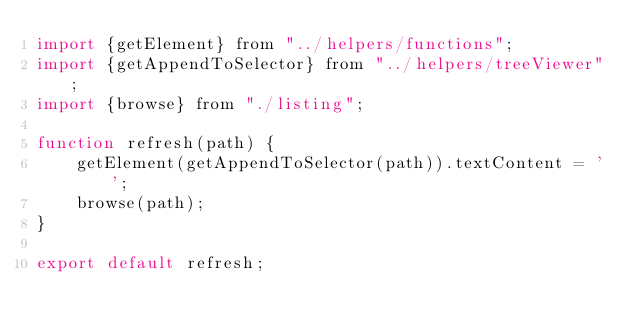Convert code to text. <code><loc_0><loc_0><loc_500><loc_500><_JavaScript_>import {getElement} from "../helpers/functions";
import {getAppendToSelector} from "../helpers/treeViewer";
import {browse} from "./listing";

function refresh(path) {
    getElement(getAppendToSelector(path)).textContent = '';
    browse(path);
}

export default refresh;</code> 